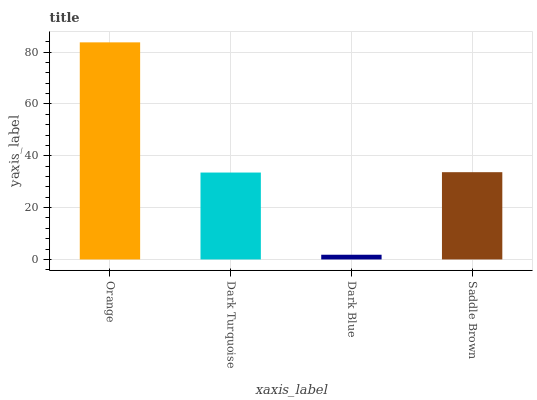Is Dark Blue the minimum?
Answer yes or no. Yes. Is Orange the maximum?
Answer yes or no. Yes. Is Dark Turquoise the minimum?
Answer yes or no. No. Is Dark Turquoise the maximum?
Answer yes or no. No. Is Orange greater than Dark Turquoise?
Answer yes or no. Yes. Is Dark Turquoise less than Orange?
Answer yes or no. Yes. Is Dark Turquoise greater than Orange?
Answer yes or no. No. Is Orange less than Dark Turquoise?
Answer yes or no. No. Is Saddle Brown the high median?
Answer yes or no. Yes. Is Dark Turquoise the low median?
Answer yes or no. Yes. Is Dark Turquoise the high median?
Answer yes or no. No. Is Orange the low median?
Answer yes or no. No. 